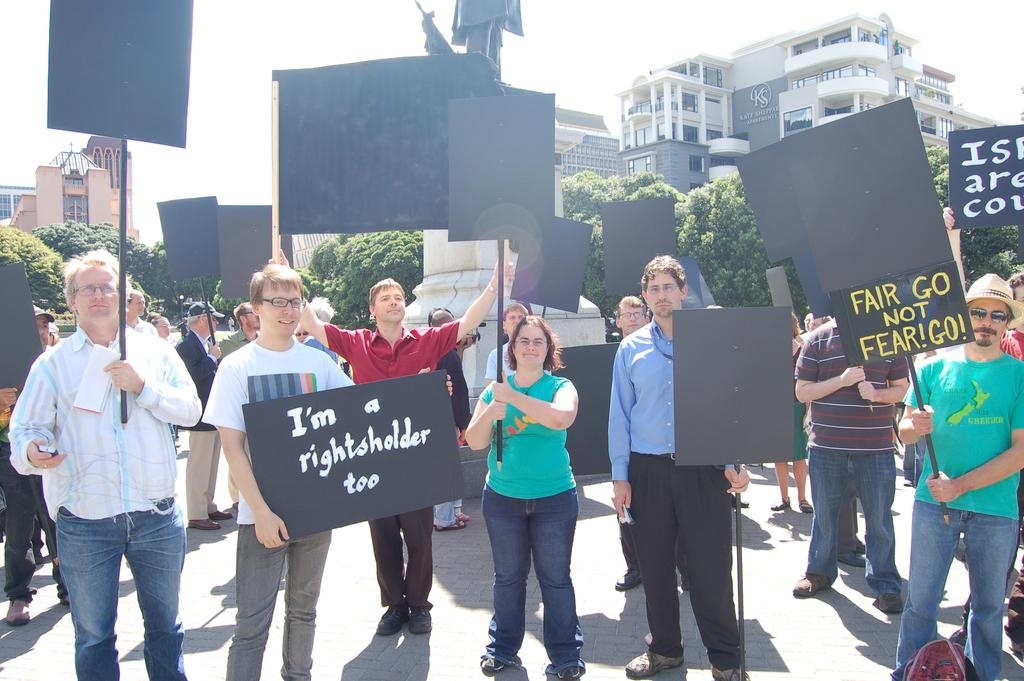What are the people in the image doing? The people in the image are standing in the center and holding boards in their hands. What can be seen in the background of the image? There are trees, buildings, and the sky visible in the background of the image. What type of washing system is being used by the people in the image? There is no washing system present in the image; the people are holding boards in their hands. 